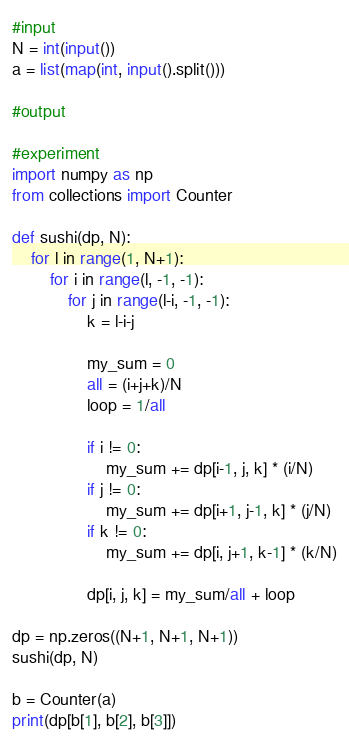<code> <loc_0><loc_0><loc_500><loc_500><_Python_>#input
N = int(input())
a = list(map(int, input().split()))

#output

#experiment
import numpy as np
from collections import Counter

def sushi(dp, N):
    for l in range(1, N+1):
        for i in range(l, -1, -1):
            for j in range(l-i, -1, -1):
                k = l-i-j

                my_sum = 0
                all = (i+j+k)/N
                loop = 1/all

                if i != 0:
                    my_sum += dp[i-1, j, k] * (i/N)
                if j != 0:
                    my_sum += dp[i+1, j-1, k] * (j/N)
                if k != 0:
                    my_sum += dp[i, j+1, k-1] * (k/N)

                dp[i, j, k] = my_sum/all + loop 

dp = np.zeros((N+1, N+1, N+1))
sushi(dp, N)

b = Counter(a)
print(dp[b[1], b[2], b[3]])</code> 